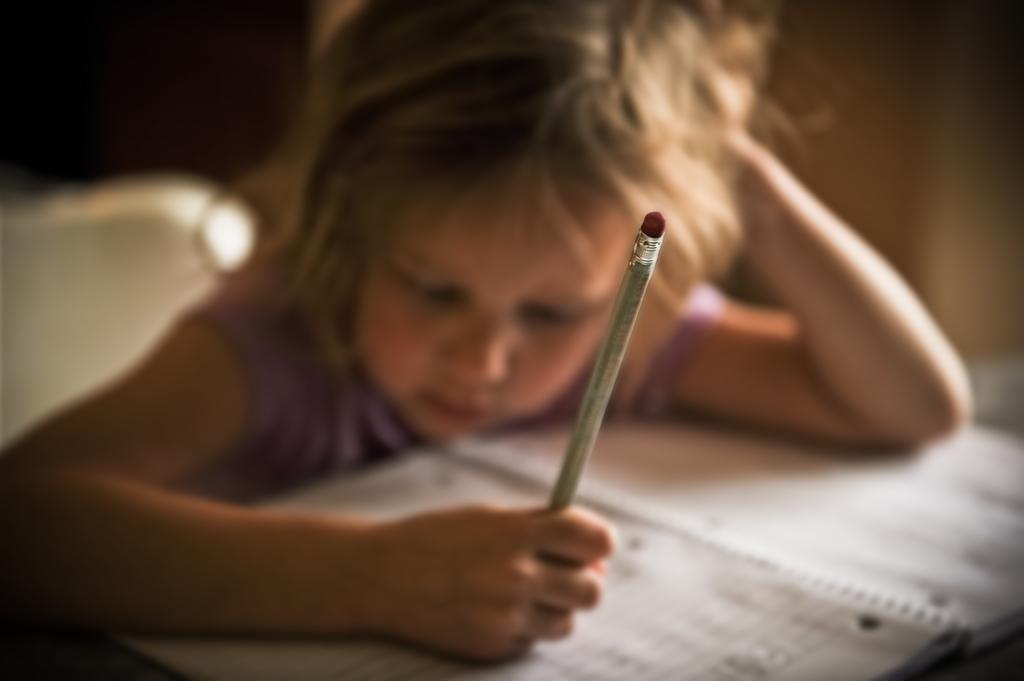What is the girl in the image doing? The girl is sitting in the image. What is the girl holding in her hands? The girl is holding a pencil in her hands. What object can be seen on the table in the image? There is a book on a table in the image. How many islands can be seen in the image? There are no islands present in the image. What type of school is depicted in the image? There is no school depicted in the image. 